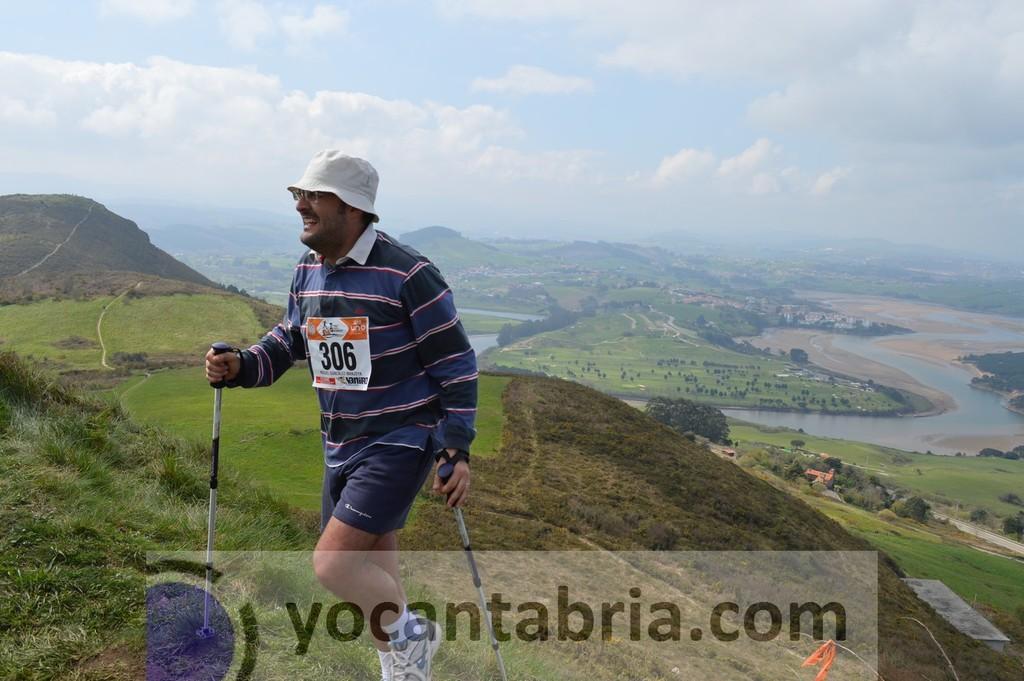Could you give a brief overview of what you see in this image? In this picture I can observe a person walking. He is holding two sticks in his hands. The person is smiling and wearing a hat on his head. I can observe some text on the bottom of the picture. In the background there are hills and some clouds in the sky. 